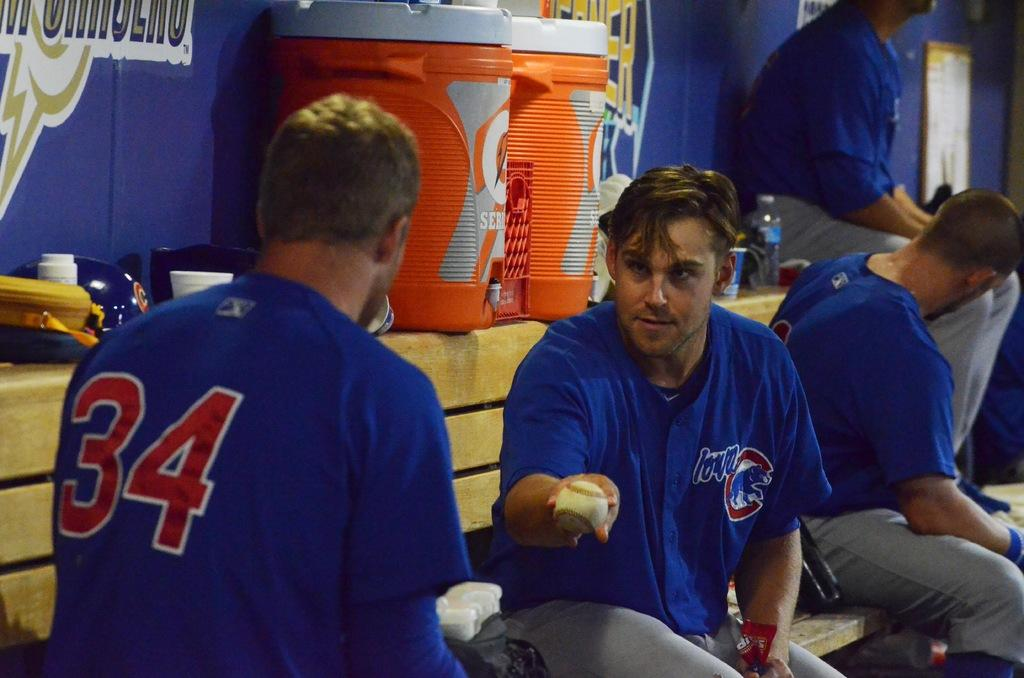<image>
Render a clear and concise summary of the photo. A guy in a jersey with the number 34 talks to another player. 